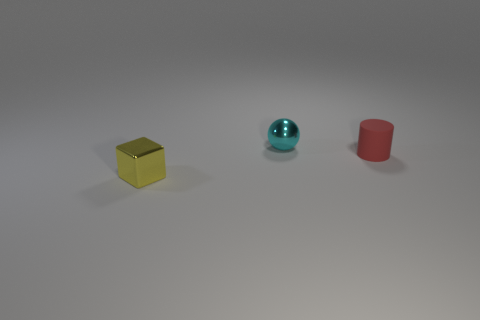Assuming these objects are part of a set, what game or activity could they be used for? Given their different shapes, they could be part of an educational toy set, intended to teach children about geometry and colors. Alternatively, they could be pieces of a tabletop game where each shape represents a different function or value, and the game's goal is to arrange them in a certain pattern or sequence based on a set of rules. 